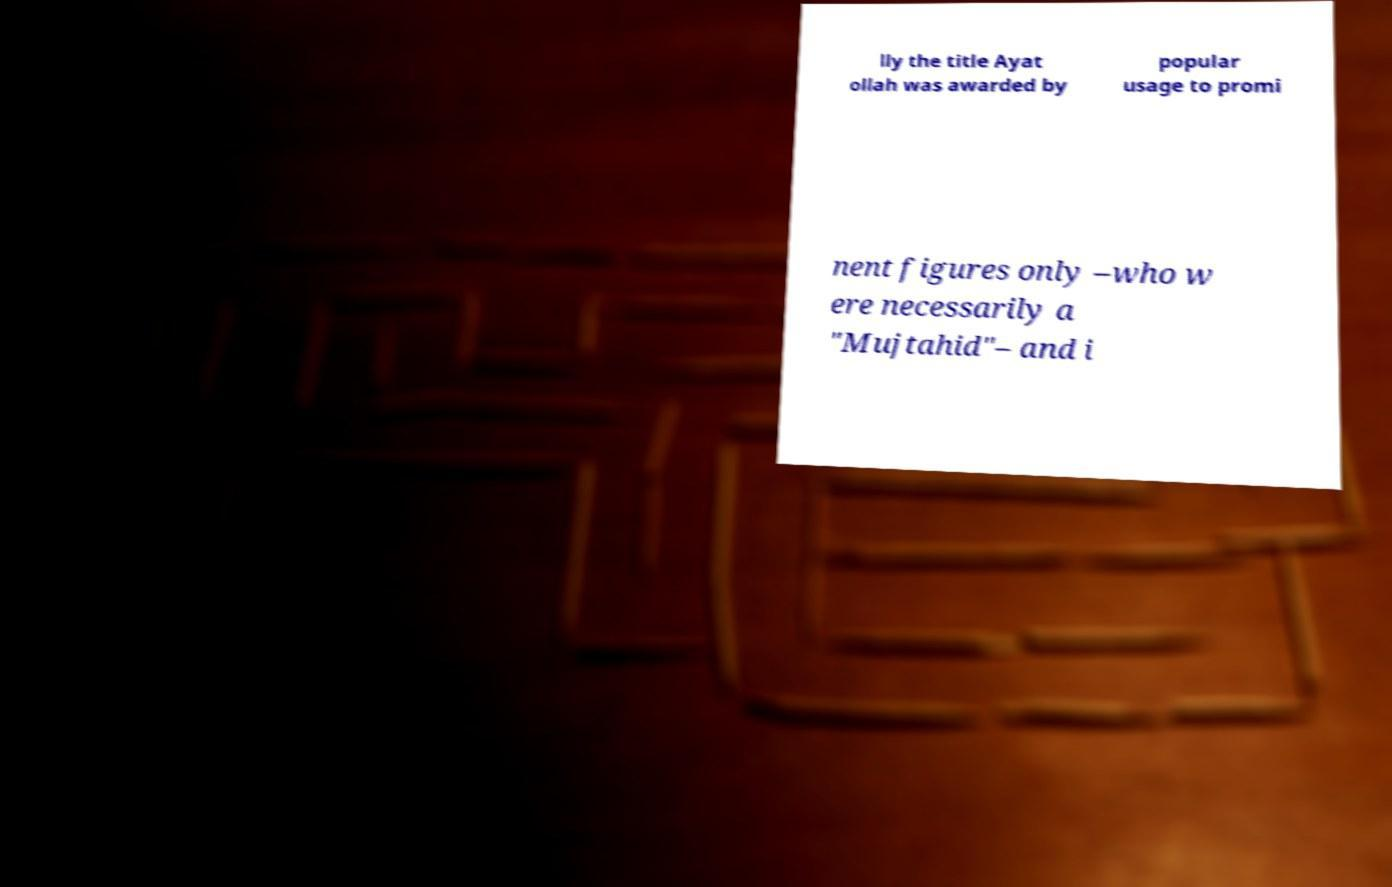Could you assist in decoding the text presented in this image and type it out clearly? lly the title Ayat ollah was awarded by popular usage to promi nent figures only –who w ere necessarily a "Mujtahid"– and i 